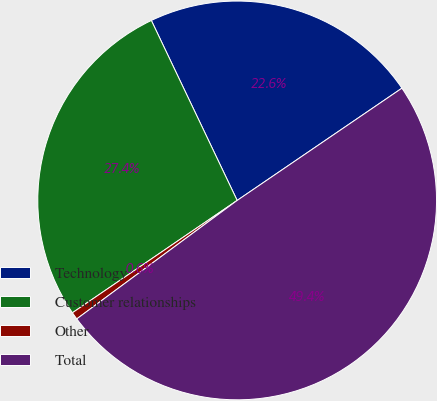Convert chart. <chart><loc_0><loc_0><loc_500><loc_500><pie_chart><fcel>Technology<fcel>Customer relationships<fcel>Other<fcel>Total<nl><fcel>22.56%<fcel>27.44%<fcel>0.6%<fcel>49.39%<nl></chart> 